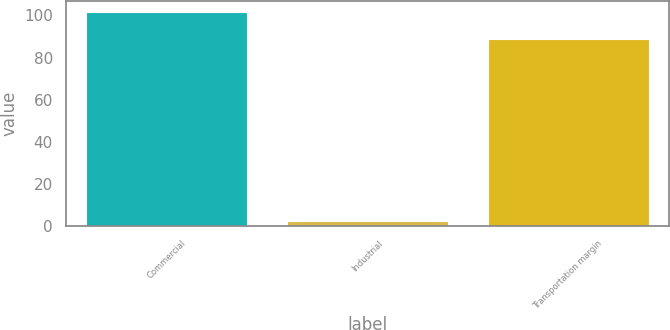Convert chart to OTSL. <chart><loc_0><loc_0><loc_500><loc_500><bar_chart><fcel>Commercial<fcel>Industrial<fcel>Transportation margin<nl><fcel>101.6<fcel>2.2<fcel>88.8<nl></chart> 